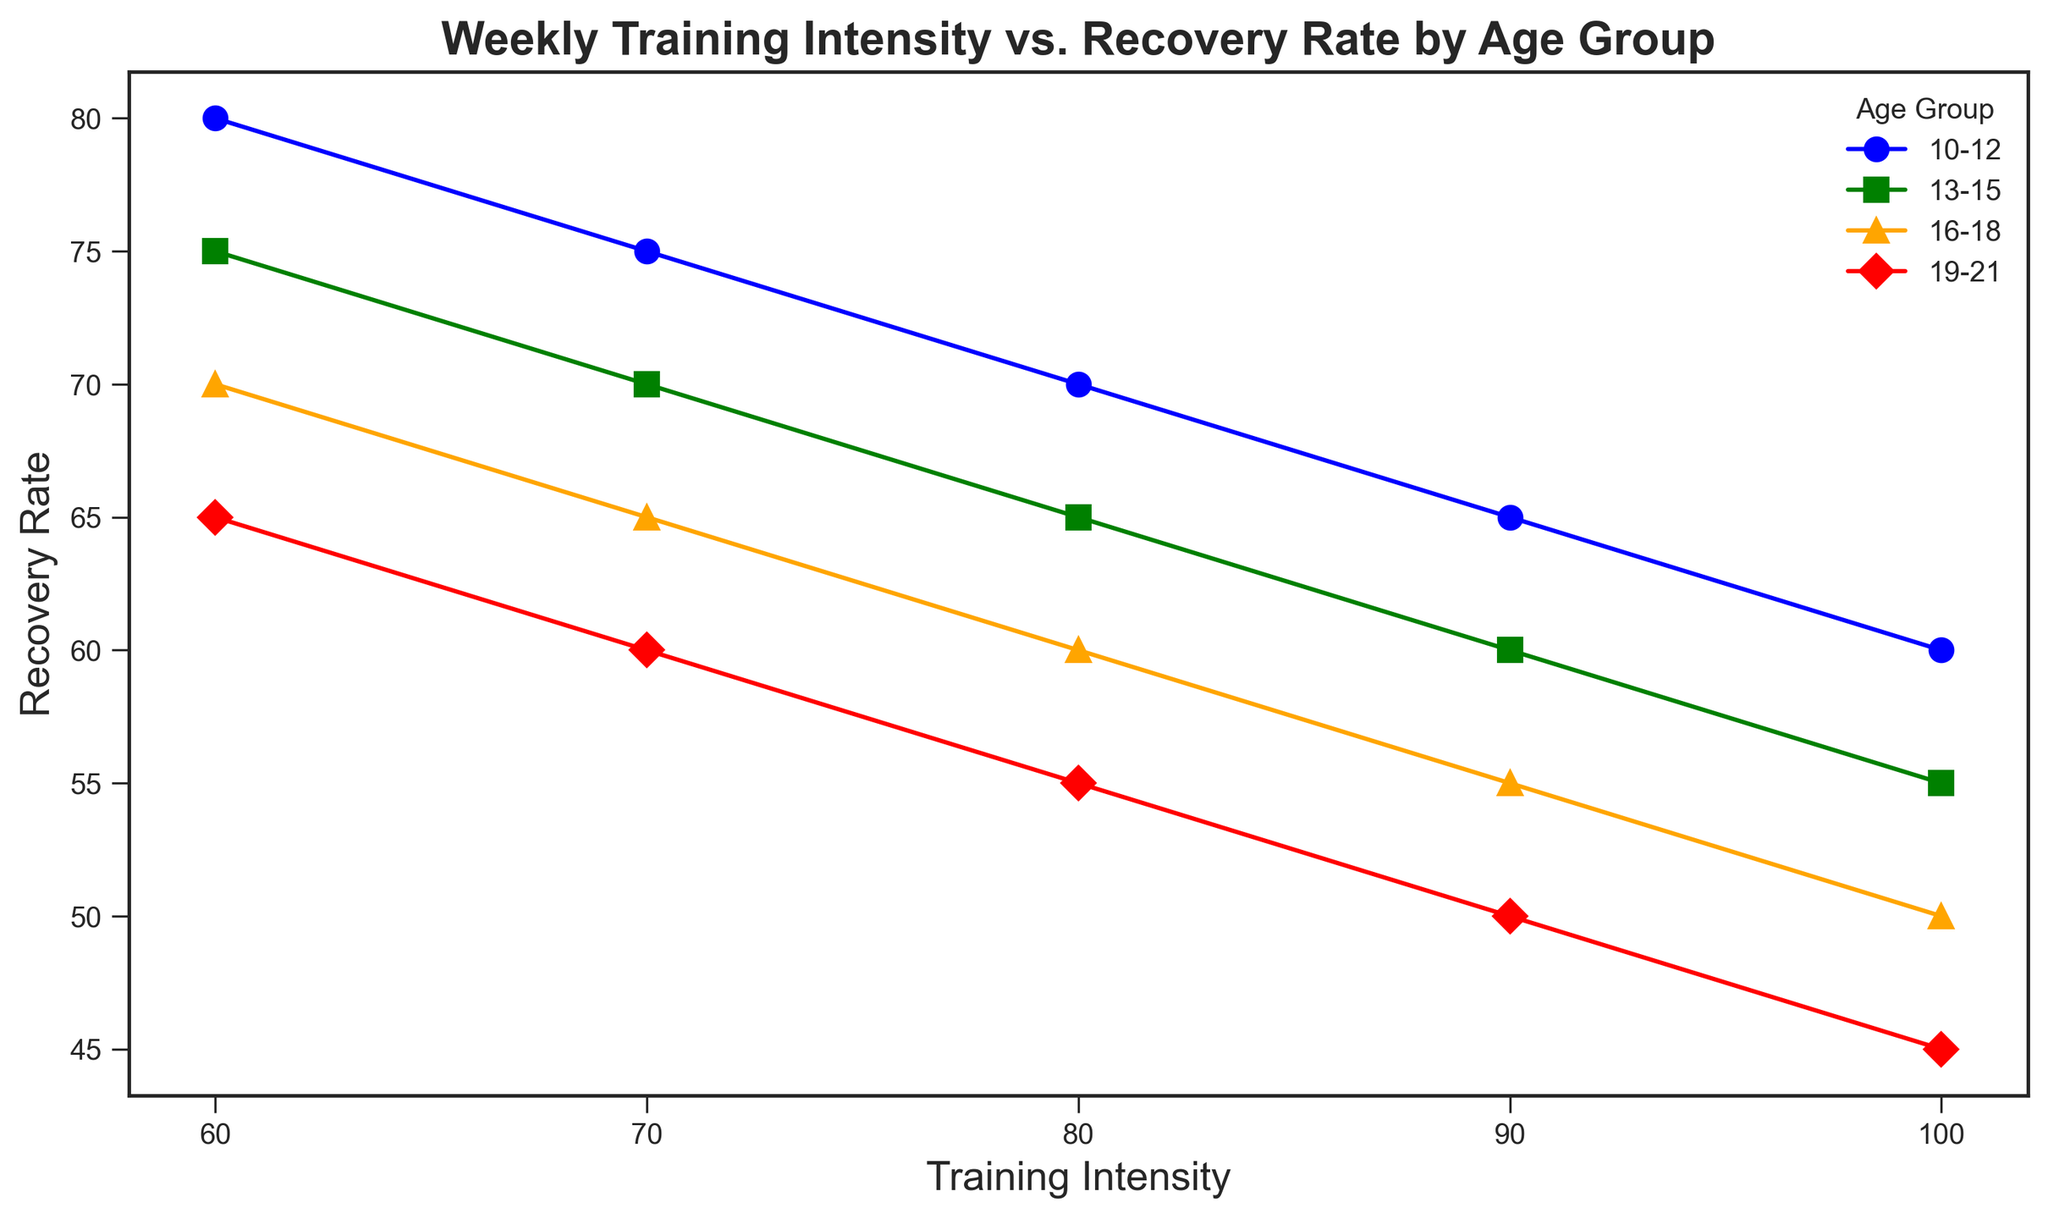What pattern or trend do the different age groups display in relation to training intensity and recovery rate? The general pattern shown in the figure indicates that as the training intensity increases, the recovery rate decreases for all age groups. However, younger age groups tend to have a higher recovery rate at the same training intensity compared to older age groups.
Answer: As training intensity increases, recovery rate decreases Which age group has the highest recovery rate at a training intensity of 70? Looking at the data points at a training intensity of 70, the age group 10-12 has the highest recovery rate, followed by age groups 13-15, 16-18, and 19-21.
Answer: 10-12 How does the recovery rate compare between the age groups 10-12 and 19-21 at a training intensity of 90? At a training intensity of 90, the age group 10-12 has a recovery rate of 65, while the age group 19-21 has a recovery rate of 50. Therefore, the recovery rate for 10-12 is higher.
Answer: 10-12 > 19-21 What is the difference in recovery rates between the youngest and oldest age groups at a training intensity of 100? At a training intensity of 100, the recovery rate for the age group 10-12 is 60, while for the age group 19-21, it is 45. The difference in recovery rates is 60 - 45.
Answer: 15 At which training intensity do all age groups show equal intervals of decrease in recovery rate? The visual representation indicates that the reduction in recovery rate appears consistent across age groups as training intensity increases, but at different magnitudes specific to each group. Equal intervals of decrease can be observed at any of the interval points (60, 70, 80, 90, 100) since the pattern is linear.
Answer: 60, 70, 80, 90, 100 Are there any age groups that display a unique trend in recovery rate compared to training intensity? All age groups display a similar trend where recovery rates decrease as training intensity increases. No age group shows a uniquely different trend in the context of this data.
Answer: No Which age group displays the steepest decline in recovery rate as training intensity increases? The age group 19-21 shows the steepest decline in recovery rate as training intensity increases, illustrated by the slope of the red line being steeper compared to other lines.
Answer: 19-21 What is the average recovery rate for the age group 16-18 across all training intensities? To calculate the average recovery rate for the age group 16-18, sum the recovery rates (70 + 65 + 60 + 55 + 50) and divide the total by the number of data points (5). The sum is 300, thus the average is 300/5.
Answer: 60 Which age group has the smallest variability in recovery rates across the training intensities? By observing the vertical spread of recovery rates within each age group, the age group 19-21 shows the smallest variability as the differences between successive recovery rates are more consistently spaced compared to other groups.
Answer: 19-21 At a training intensity of 80, what can you infer about the recovery rates across all age groups? At a training intensity of 80, the recovery rates decrease progressively with age: 70 for age group 10-12, 65 for 13-15, 60 for 16-18, and 55 for 19-21. This implies that younger athletes recover better at this intensity level.
Answer: Recovery rates decrease with age 